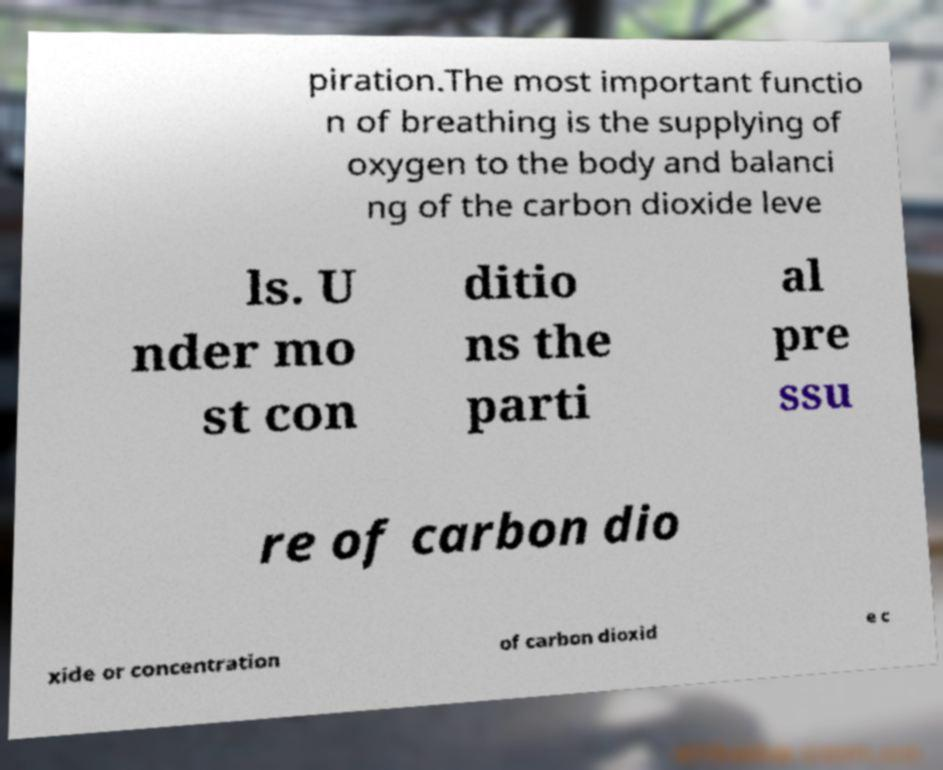Can you accurately transcribe the text from the provided image for me? piration.The most important functio n of breathing is the supplying of oxygen to the body and balanci ng of the carbon dioxide leve ls. U nder mo st con ditio ns the parti al pre ssu re of carbon dio xide or concentration of carbon dioxid e c 